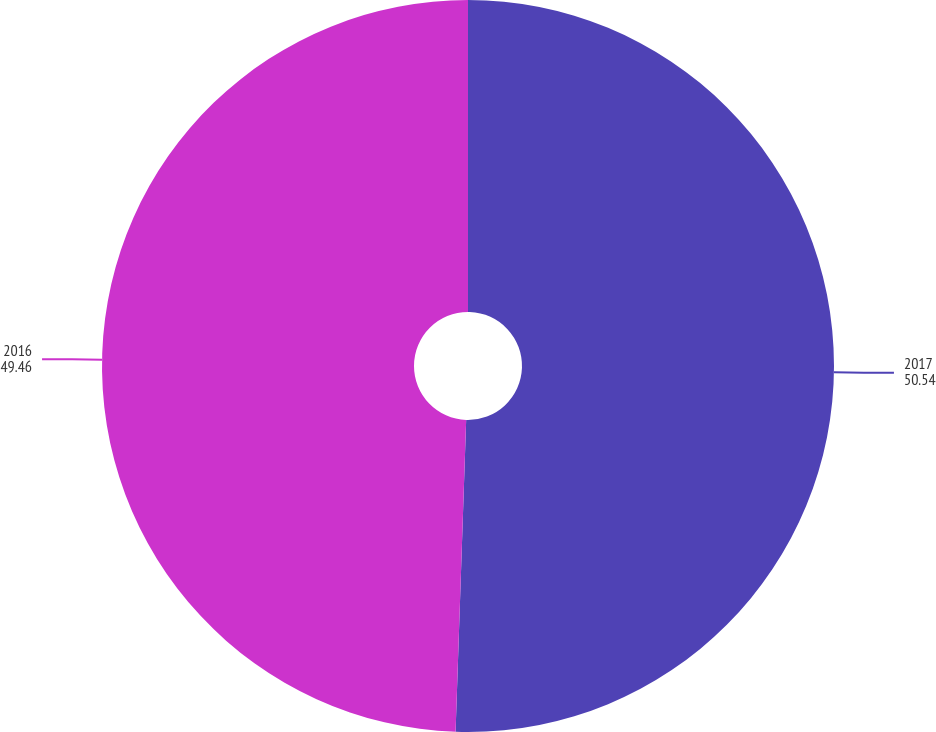Convert chart to OTSL. <chart><loc_0><loc_0><loc_500><loc_500><pie_chart><fcel>2017<fcel>2016<nl><fcel>50.54%<fcel>49.46%<nl></chart> 